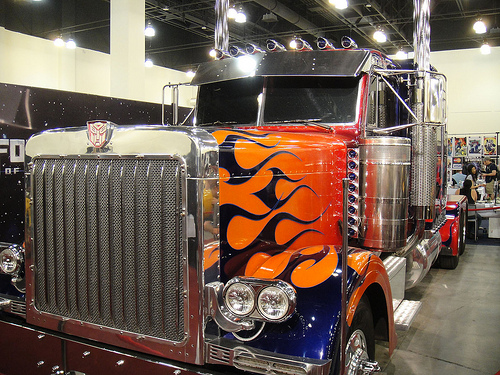<image>
Can you confirm if the flames is on the truck? Yes. Looking at the image, I can see the flames is positioned on top of the truck, with the truck providing support. 